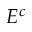Convert formula to latex. <formula><loc_0><loc_0><loc_500><loc_500>E ^ { c }</formula> 